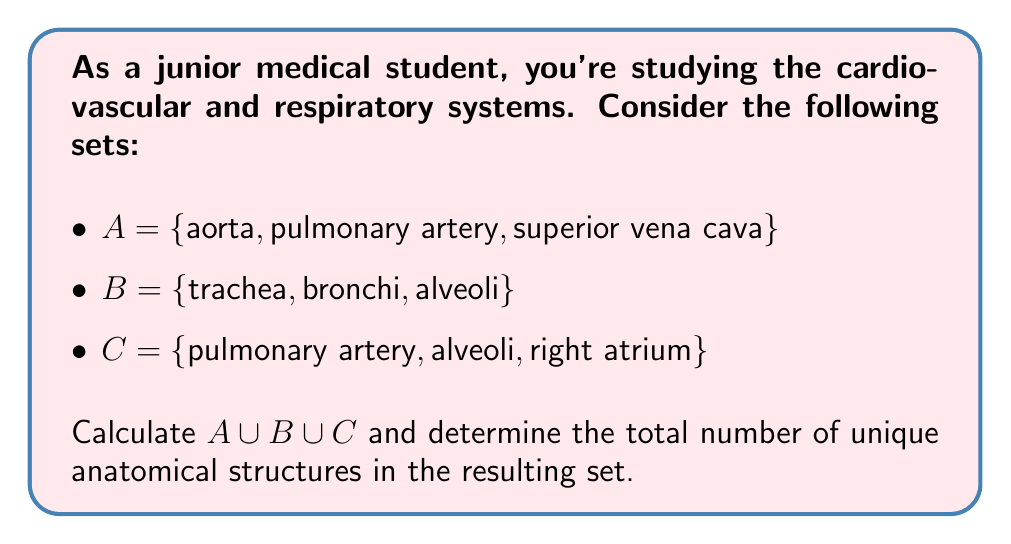What is the answer to this math problem? To solve this problem, we need to follow these steps:

1. Identify all unique elements in sets A, B, and C.
2. Combine these elements into a single set (the union).
3. Count the number of elements in the resulting set.

Let's break it down:

1. Set A: {aorta, pulmonary artery, superior vena cava}
2. Set B: {trachea, bronchi, alveoli}
3. Set C: {pulmonary artery, alveoli, right atrium}

Now, let's combine these sets:

$A \cup B \cup C = \{$ aorta, pulmonary artery, superior vena cava, trachea, bronchi, alveoli, right atrium $\}$

Note that "pulmonary artery" appears in both A and C, and "alveoli" appears in both B and C. In a set, we only include each element once, regardless of how many times it appears in the original sets.

To count the number of unique elements, we simply count each element in our resulting set:

1. aorta
2. pulmonary artery
3. superior vena cava
4. trachea
5. bronchi
6. alveoli
7. right atrium

Therefore, there are 7 unique anatomical structures in the union of sets A, B, and C.
Answer: 7 